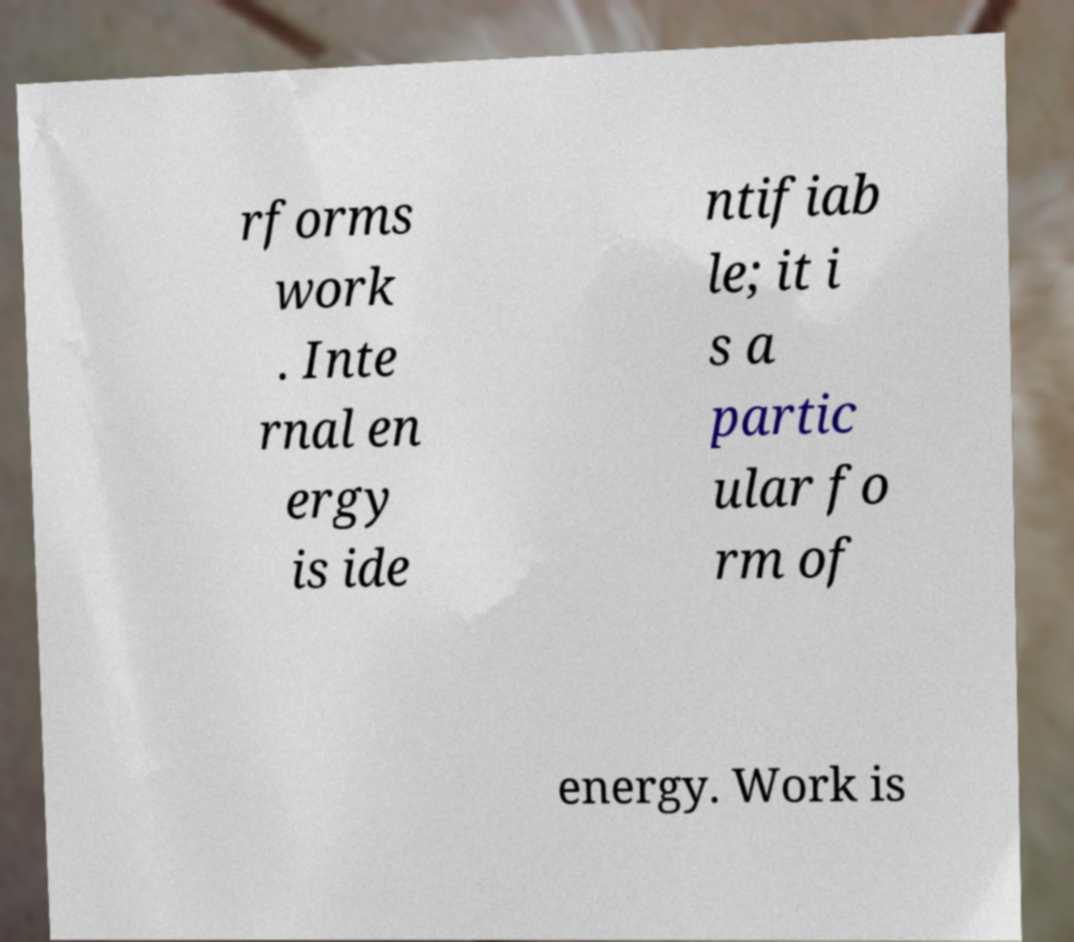Can you read and provide the text displayed in the image?This photo seems to have some interesting text. Can you extract and type it out for me? rforms work . Inte rnal en ergy is ide ntifiab le; it i s a partic ular fo rm of energy. Work is 